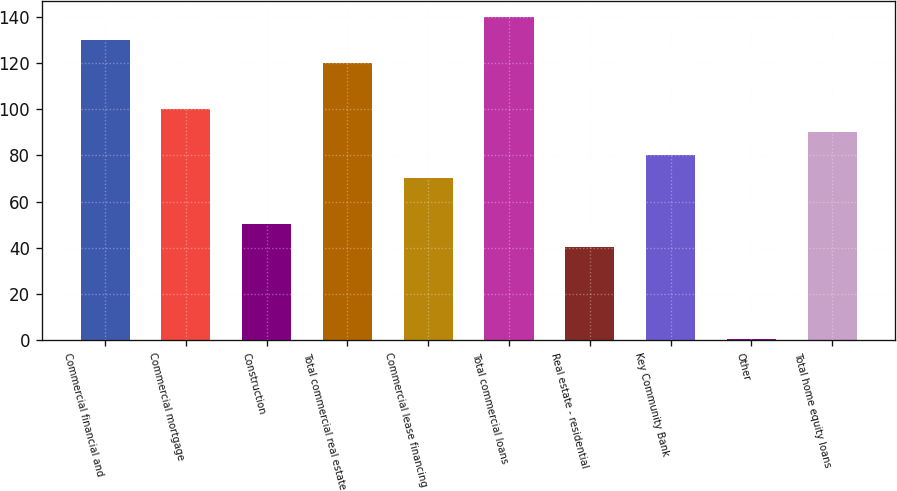Convert chart to OTSL. <chart><loc_0><loc_0><loc_500><loc_500><bar_chart><fcel>Commercial financial and<fcel>Commercial mortgage<fcel>Construction<fcel>Total commercial real estate<fcel>Commercial lease financing<fcel>Total commercial loans<fcel>Real estate - residential<fcel>Key Community Bank<fcel>Other<fcel>Total home equity loans<nl><fcel>129.82<fcel>100<fcel>50.3<fcel>119.88<fcel>70.18<fcel>139.76<fcel>40.36<fcel>80.12<fcel>0.6<fcel>90.06<nl></chart> 